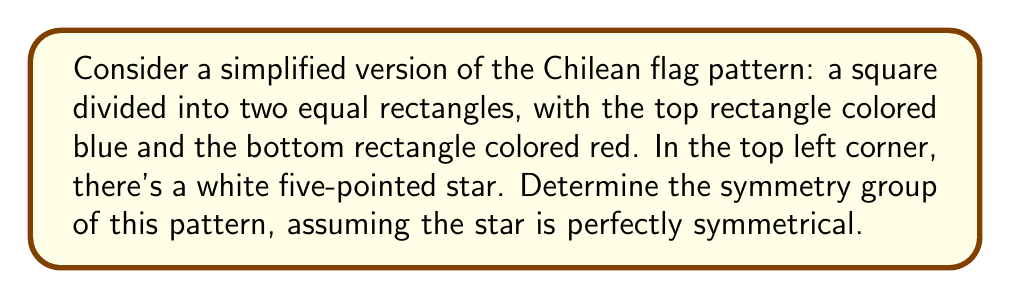Can you answer this question? To determine the symmetry group of this pattern, we need to identify all the symmetry operations that leave the pattern unchanged. Let's approach this step-by-step:

1) Rotational symmetry:
   The pattern does not have any rotational symmetry other than the identity (360° rotation), as any non-trivial rotation would disrupt the arrangement of colors and the position of the star.

2) Reflection symmetry:
   The only line of reflection that preserves the pattern is the vertical line that bisects the flag from top to bottom. This reflection keeps the blue on top, red on bottom, and maintains the star's position in the top left corner.

3) Translation symmetry:
   There are no non-trivial translations that preserve the pattern due to its finite size and unique elements.

Now, let's identify the symmetry operations:
- e: Identity operation (do nothing)
- r: Reflection about the vertical bisector

These operations form a group under composition:
$$
\begin{array}{c|cc}
\circ & e & r \\
\hline
e & e & r \\
r & r & e
\end{array}
$$

This group has order 2 and is isomorphic to the cyclic group $C_2$ or the symmetric group $S_2$.

In terms of abstract algebra, this group is known as the dihedral group of order 2, denoted as $D_1$ or $\mathbb{Z}_2$.

[asy]
size(200);
fill((-1,-1)--(1,-1)--(1,0)--(-1,0)--cycle, red);
fill((-1,0)--(1,0)--(1,1)--(-1,1)--cycle, blue);
path star = (0,0.7)--(-0.2,0.2)--(0.2,0.5)--(0.2,0.5)--(-0.2,0.5)--(0,0.2)--cycle;
fill(shift(-0.7,0.7)*star, white);
draw((-1,-1)--(1,-1)--(1,1)--(-1,1)--cycle);
draw((0,-1)--(0,1), dashed);
label("Reflection axis", (0,1.1), N);
[/asy]
Answer: The symmetry group of the simplified Chilean flag pattern is isomorphic to $\mathbb{Z}_2$, the cyclic group of order 2. 